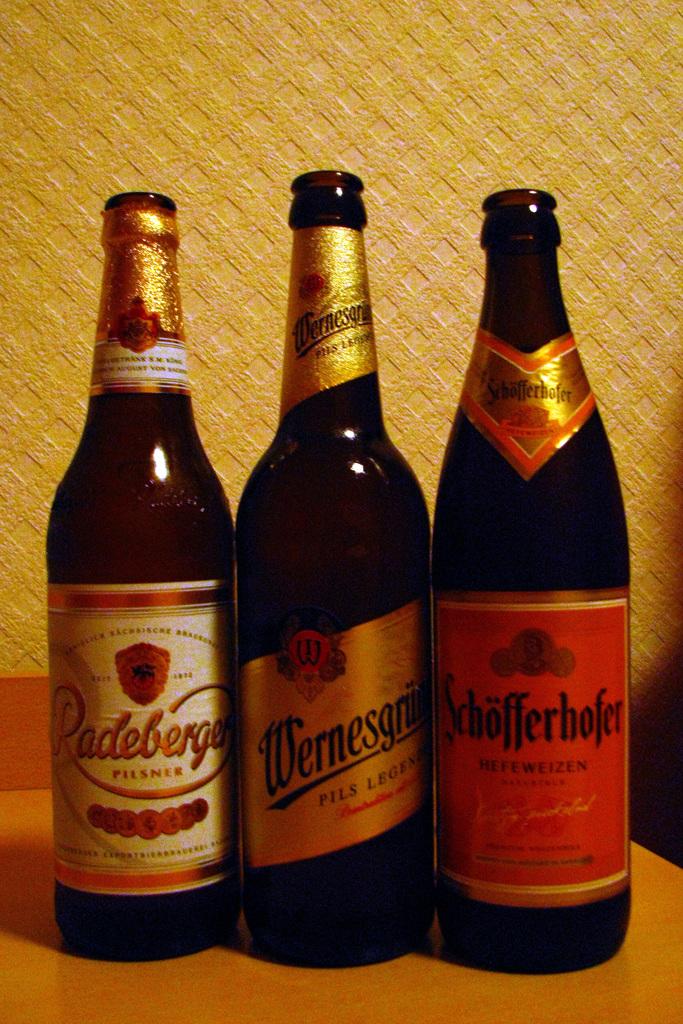What type of beer is in the bottle on the left?
Provide a succinct answer. Padeberger. What brand is the beer on the right?
Offer a terse response. Schofferhofer. 